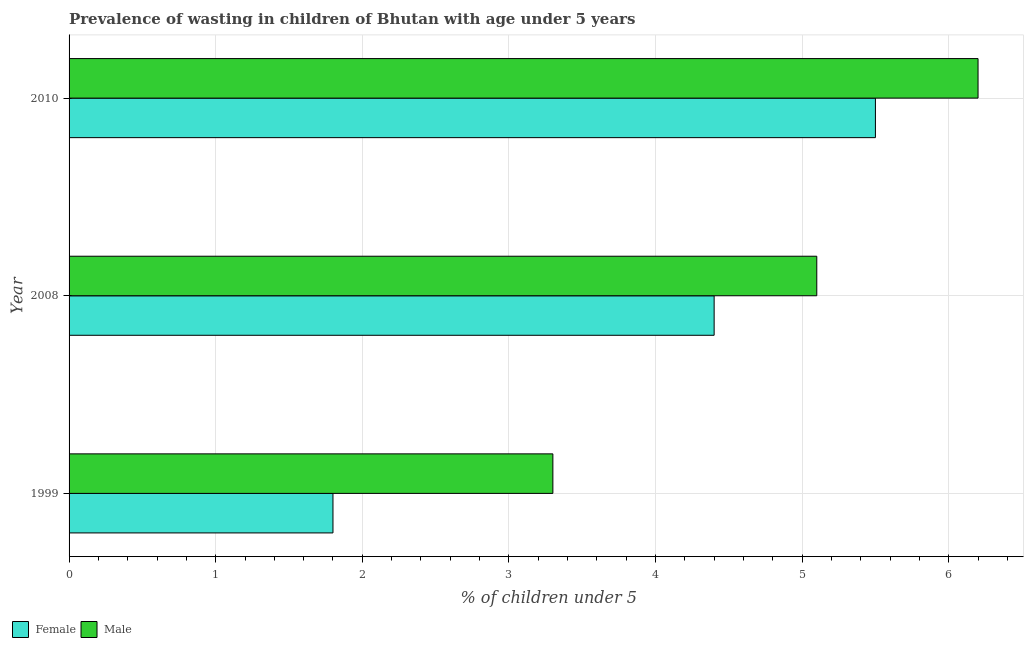Are the number of bars per tick equal to the number of legend labels?
Provide a succinct answer. Yes. How many bars are there on the 3rd tick from the top?
Your response must be concise. 2. What is the percentage of undernourished male children in 2010?
Keep it short and to the point. 6.2. Across all years, what is the minimum percentage of undernourished male children?
Keep it short and to the point. 3.3. In which year was the percentage of undernourished female children maximum?
Your answer should be very brief. 2010. In which year was the percentage of undernourished male children minimum?
Offer a terse response. 1999. What is the total percentage of undernourished female children in the graph?
Provide a short and direct response. 11.7. What is the difference between the percentage of undernourished male children in 1999 and that in 2010?
Your answer should be very brief. -2.9. What is the difference between the percentage of undernourished female children in 2010 and the percentage of undernourished male children in 1999?
Offer a terse response. 2.2. In how many years, is the percentage of undernourished male children greater than 2.6 %?
Your answer should be compact. 3. What is the ratio of the percentage of undernourished female children in 2008 to that in 2010?
Your answer should be compact. 0.8. Is the difference between the percentage of undernourished female children in 1999 and 2008 greater than the difference between the percentage of undernourished male children in 1999 and 2008?
Your answer should be compact. No. What is the difference between the highest and the second highest percentage of undernourished female children?
Make the answer very short. 1.1. Is the sum of the percentage of undernourished male children in 1999 and 2010 greater than the maximum percentage of undernourished female children across all years?
Provide a succinct answer. Yes. What does the 1st bar from the bottom in 2010 represents?
Offer a very short reply. Female. How many bars are there?
Offer a very short reply. 6. How many years are there in the graph?
Provide a short and direct response. 3. Are the values on the major ticks of X-axis written in scientific E-notation?
Ensure brevity in your answer.  No. Does the graph contain grids?
Make the answer very short. Yes. Where does the legend appear in the graph?
Your response must be concise. Bottom left. What is the title of the graph?
Provide a succinct answer. Prevalence of wasting in children of Bhutan with age under 5 years. Does "All education staff compensation" appear as one of the legend labels in the graph?
Ensure brevity in your answer.  No. What is the label or title of the X-axis?
Offer a terse response.  % of children under 5. What is the label or title of the Y-axis?
Provide a succinct answer. Year. What is the  % of children under 5 in Female in 1999?
Give a very brief answer. 1.8. What is the  % of children under 5 in Male in 1999?
Your response must be concise. 3.3. What is the  % of children under 5 in Female in 2008?
Give a very brief answer. 4.4. What is the  % of children under 5 of Male in 2008?
Keep it short and to the point. 5.1. What is the  % of children under 5 of Male in 2010?
Your answer should be very brief. 6.2. Across all years, what is the maximum  % of children under 5 of Female?
Provide a succinct answer. 5.5. Across all years, what is the maximum  % of children under 5 of Male?
Provide a short and direct response. 6.2. Across all years, what is the minimum  % of children under 5 of Female?
Provide a succinct answer. 1.8. Across all years, what is the minimum  % of children under 5 of Male?
Ensure brevity in your answer.  3.3. What is the total  % of children under 5 of Female in the graph?
Provide a succinct answer. 11.7. What is the difference between the  % of children under 5 in Female in 1999 and that in 2008?
Give a very brief answer. -2.6. What is the difference between the  % of children under 5 in Male in 1999 and that in 2008?
Ensure brevity in your answer.  -1.8. What is the difference between the  % of children under 5 in Male in 2008 and that in 2010?
Offer a terse response. -1.1. What is the difference between the  % of children under 5 in Female in 1999 and the  % of children under 5 in Male in 2008?
Offer a very short reply. -3.3. What is the difference between the  % of children under 5 of Female in 2008 and the  % of children under 5 of Male in 2010?
Your answer should be compact. -1.8. What is the average  % of children under 5 of Female per year?
Offer a terse response. 3.9. What is the average  % of children under 5 in Male per year?
Your response must be concise. 4.87. In the year 2008, what is the difference between the  % of children under 5 in Female and  % of children under 5 in Male?
Your answer should be very brief. -0.7. In the year 2010, what is the difference between the  % of children under 5 of Female and  % of children under 5 of Male?
Offer a terse response. -0.7. What is the ratio of the  % of children under 5 in Female in 1999 to that in 2008?
Offer a terse response. 0.41. What is the ratio of the  % of children under 5 of Male in 1999 to that in 2008?
Keep it short and to the point. 0.65. What is the ratio of the  % of children under 5 in Female in 1999 to that in 2010?
Give a very brief answer. 0.33. What is the ratio of the  % of children under 5 of Male in 1999 to that in 2010?
Your answer should be very brief. 0.53. What is the ratio of the  % of children under 5 of Male in 2008 to that in 2010?
Give a very brief answer. 0.82. What is the difference between the highest and the lowest  % of children under 5 of Female?
Keep it short and to the point. 3.7. What is the difference between the highest and the lowest  % of children under 5 in Male?
Provide a short and direct response. 2.9. 